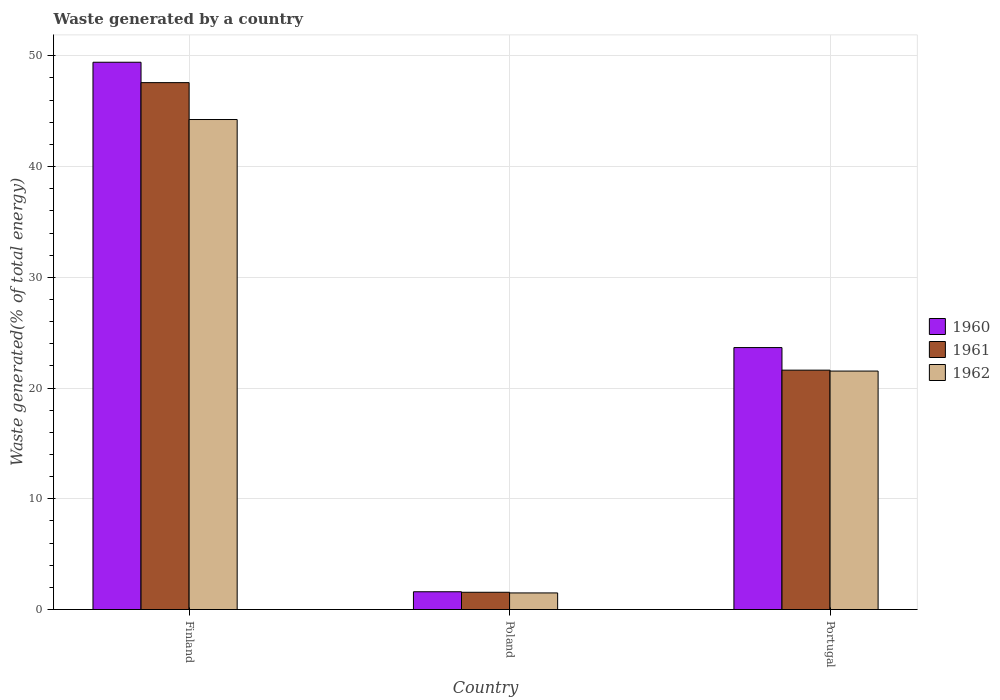Are the number of bars on each tick of the X-axis equal?
Offer a terse response. Yes. What is the total waste generated in 1962 in Poland?
Your answer should be very brief. 1.5. Across all countries, what is the maximum total waste generated in 1960?
Keep it short and to the point. 49.42. Across all countries, what is the minimum total waste generated in 1960?
Your response must be concise. 1.6. In which country was the total waste generated in 1962 maximum?
Provide a short and direct response. Finland. In which country was the total waste generated in 1962 minimum?
Provide a short and direct response. Poland. What is the total total waste generated in 1962 in the graph?
Keep it short and to the point. 67.28. What is the difference between the total waste generated in 1961 in Finland and that in Poland?
Give a very brief answer. 46.02. What is the difference between the total waste generated in 1962 in Poland and the total waste generated in 1960 in Portugal?
Your answer should be compact. -22.16. What is the average total waste generated in 1960 per country?
Your response must be concise. 24.89. What is the difference between the total waste generated of/in 1960 and total waste generated of/in 1961 in Portugal?
Offer a terse response. 2.04. What is the ratio of the total waste generated in 1960 in Finland to that in Portugal?
Your response must be concise. 2.09. Is the total waste generated in 1961 in Finland less than that in Poland?
Make the answer very short. No. What is the difference between the highest and the second highest total waste generated in 1962?
Provide a short and direct response. -42.75. What is the difference between the highest and the lowest total waste generated in 1961?
Provide a succinct answer. 46.02. Is the sum of the total waste generated in 1960 in Finland and Poland greater than the maximum total waste generated in 1962 across all countries?
Provide a succinct answer. Yes. What does the 3rd bar from the left in Poland represents?
Provide a short and direct response. 1962. What does the 2nd bar from the right in Finland represents?
Your response must be concise. 1961. Is it the case that in every country, the sum of the total waste generated in 1961 and total waste generated in 1962 is greater than the total waste generated in 1960?
Keep it short and to the point. Yes. Are all the bars in the graph horizontal?
Offer a terse response. No. What is the difference between two consecutive major ticks on the Y-axis?
Give a very brief answer. 10. What is the title of the graph?
Give a very brief answer. Waste generated by a country. Does "1984" appear as one of the legend labels in the graph?
Offer a very short reply. No. What is the label or title of the Y-axis?
Offer a terse response. Waste generated(% of total energy). What is the Waste generated(% of total energy) in 1960 in Finland?
Your answer should be compact. 49.42. What is the Waste generated(% of total energy) of 1961 in Finland?
Your answer should be compact. 47.58. What is the Waste generated(% of total energy) in 1962 in Finland?
Make the answer very short. 44.25. What is the Waste generated(% of total energy) in 1960 in Poland?
Provide a short and direct response. 1.6. What is the Waste generated(% of total energy) in 1961 in Poland?
Offer a very short reply. 1.56. What is the Waste generated(% of total energy) of 1962 in Poland?
Give a very brief answer. 1.5. What is the Waste generated(% of total energy) of 1960 in Portugal?
Keep it short and to the point. 23.66. What is the Waste generated(% of total energy) in 1961 in Portugal?
Your answer should be compact. 21.62. What is the Waste generated(% of total energy) in 1962 in Portugal?
Give a very brief answer. 21.53. Across all countries, what is the maximum Waste generated(% of total energy) in 1960?
Provide a succinct answer. 49.42. Across all countries, what is the maximum Waste generated(% of total energy) of 1961?
Give a very brief answer. 47.58. Across all countries, what is the maximum Waste generated(% of total energy) in 1962?
Your answer should be very brief. 44.25. Across all countries, what is the minimum Waste generated(% of total energy) of 1960?
Offer a very short reply. 1.6. Across all countries, what is the minimum Waste generated(% of total energy) in 1961?
Give a very brief answer. 1.56. Across all countries, what is the minimum Waste generated(% of total energy) in 1962?
Make the answer very short. 1.5. What is the total Waste generated(% of total energy) of 1960 in the graph?
Give a very brief answer. 74.68. What is the total Waste generated(% of total energy) in 1961 in the graph?
Your answer should be very brief. 70.76. What is the total Waste generated(% of total energy) in 1962 in the graph?
Offer a terse response. 67.28. What is the difference between the Waste generated(% of total energy) of 1960 in Finland and that in Poland?
Offer a terse response. 47.82. What is the difference between the Waste generated(% of total energy) of 1961 in Finland and that in Poland?
Your answer should be very brief. 46.02. What is the difference between the Waste generated(% of total energy) in 1962 in Finland and that in Poland?
Your response must be concise. 42.75. What is the difference between the Waste generated(% of total energy) in 1960 in Finland and that in Portugal?
Give a very brief answer. 25.77. What is the difference between the Waste generated(% of total energy) of 1961 in Finland and that in Portugal?
Provide a short and direct response. 25.96. What is the difference between the Waste generated(% of total energy) in 1962 in Finland and that in Portugal?
Provide a short and direct response. 22.72. What is the difference between the Waste generated(% of total energy) of 1960 in Poland and that in Portugal?
Ensure brevity in your answer.  -22.05. What is the difference between the Waste generated(% of total energy) in 1961 in Poland and that in Portugal?
Offer a very short reply. -20.06. What is the difference between the Waste generated(% of total energy) in 1962 in Poland and that in Portugal?
Your answer should be very brief. -20.03. What is the difference between the Waste generated(% of total energy) of 1960 in Finland and the Waste generated(% of total energy) of 1961 in Poland?
Provide a succinct answer. 47.86. What is the difference between the Waste generated(% of total energy) in 1960 in Finland and the Waste generated(% of total energy) in 1962 in Poland?
Make the answer very short. 47.92. What is the difference between the Waste generated(% of total energy) in 1961 in Finland and the Waste generated(% of total energy) in 1962 in Poland?
Give a very brief answer. 46.08. What is the difference between the Waste generated(% of total energy) in 1960 in Finland and the Waste generated(% of total energy) in 1961 in Portugal?
Provide a short and direct response. 27.81. What is the difference between the Waste generated(% of total energy) of 1960 in Finland and the Waste generated(% of total energy) of 1962 in Portugal?
Offer a very short reply. 27.89. What is the difference between the Waste generated(% of total energy) in 1961 in Finland and the Waste generated(% of total energy) in 1962 in Portugal?
Keep it short and to the point. 26.05. What is the difference between the Waste generated(% of total energy) of 1960 in Poland and the Waste generated(% of total energy) of 1961 in Portugal?
Make the answer very short. -20.01. What is the difference between the Waste generated(% of total energy) of 1960 in Poland and the Waste generated(% of total energy) of 1962 in Portugal?
Ensure brevity in your answer.  -19.93. What is the difference between the Waste generated(% of total energy) in 1961 in Poland and the Waste generated(% of total energy) in 1962 in Portugal?
Offer a very short reply. -19.98. What is the average Waste generated(% of total energy) of 1960 per country?
Give a very brief answer. 24.89. What is the average Waste generated(% of total energy) of 1961 per country?
Keep it short and to the point. 23.59. What is the average Waste generated(% of total energy) of 1962 per country?
Keep it short and to the point. 22.43. What is the difference between the Waste generated(% of total energy) in 1960 and Waste generated(% of total energy) in 1961 in Finland?
Your response must be concise. 1.84. What is the difference between the Waste generated(% of total energy) of 1960 and Waste generated(% of total energy) of 1962 in Finland?
Provide a succinct answer. 5.17. What is the difference between the Waste generated(% of total energy) in 1961 and Waste generated(% of total energy) in 1962 in Finland?
Keep it short and to the point. 3.33. What is the difference between the Waste generated(% of total energy) in 1960 and Waste generated(% of total energy) in 1961 in Poland?
Provide a succinct answer. 0.05. What is the difference between the Waste generated(% of total energy) of 1960 and Waste generated(% of total energy) of 1962 in Poland?
Your response must be concise. 0.11. What is the difference between the Waste generated(% of total energy) in 1961 and Waste generated(% of total energy) in 1962 in Poland?
Offer a very short reply. 0.06. What is the difference between the Waste generated(% of total energy) of 1960 and Waste generated(% of total energy) of 1961 in Portugal?
Ensure brevity in your answer.  2.04. What is the difference between the Waste generated(% of total energy) in 1960 and Waste generated(% of total energy) in 1962 in Portugal?
Give a very brief answer. 2.12. What is the difference between the Waste generated(% of total energy) of 1961 and Waste generated(% of total energy) of 1962 in Portugal?
Your response must be concise. 0.08. What is the ratio of the Waste generated(% of total energy) of 1960 in Finland to that in Poland?
Make the answer very short. 30.8. What is the ratio of the Waste generated(% of total energy) of 1961 in Finland to that in Poland?
Provide a succinct answer. 30.53. What is the ratio of the Waste generated(% of total energy) of 1962 in Finland to that in Poland?
Keep it short and to the point. 29.52. What is the ratio of the Waste generated(% of total energy) of 1960 in Finland to that in Portugal?
Offer a terse response. 2.09. What is the ratio of the Waste generated(% of total energy) of 1961 in Finland to that in Portugal?
Ensure brevity in your answer.  2.2. What is the ratio of the Waste generated(% of total energy) of 1962 in Finland to that in Portugal?
Provide a succinct answer. 2.05. What is the ratio of the Waste generated(% of total energy) in 1960 in Poland to that in Portugal?
Make the answer very short. 0.07. What is the ratio of the Waste generated(% of total energy) in 1961 in Poland to that in Portugal?
Your answer should be very brief. 0.07. What is the ratio of the Waste generated(% of total energy) in 1962 in Poland to that in Portugal?
Offer a terse response. 0.07. What is the difference between the highest and the second highest Waste generated(% of total energy) in 1960?
Offer a very short reply. 25.77. What is the difference between the highest and the second highest Waste generated(% of total energy) in 1961?
Keep it short and to the point. 25.96. What is the difference between the highest and the second highest Waste generated(% of total energy) of 1962?
Provide a succinct answer. 22.72. What is the difference between the highest and the lowest Waste generated(% of total energy) in 1960?
Provide a succinct answer. 47.82. What is the difference between the highest and the lowest Waste generated(% of total energy) of 1961?
Offer a very short reply. 46.02. What is the difference between the highest and the lowest Waste generated(% of total energy) in 1962?
Your answer should be compact. 42.75. 